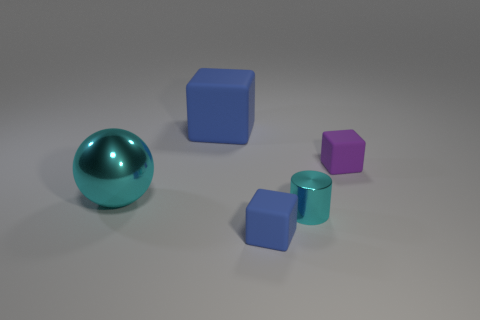Is there anything else that has the same size as the cyan ball?
Your response must be concise. Yes. Does the small blue matte object have the same shape as the large blue object?
Offer a very short reply. Yes. Are there fewer tiny objects that are in front of the cyan cylinder than tiny cyan things that are behind the large blue block?
Your answer should be very brief. No. There is a tiny cyan shiny cylinder; what number of small cyan metal cylinders are to the right of it?
Give a very brief answer. 0. Is the shape of the large thing right of the big metallic object the same as the blue object on the right side of the large blue cube?
Make the answer very short. Yes. What number of other things are there of the same color as the tiny metallic cylinder?
Provide a succinct answer. 1. The blue object in front of the blue matte block to the left of the blue rubber cube that is in front of the big cube is made of what material?
Your answer should be compact. Rubber. What is the material of the cyan object to the right of the blue matte thing that is behind the tiny cyan object?
Provide a short and direct response. Metal. Are there fewer tiny cyan metallic cylinders that are behind the cyan metal cylinder than big blue rubber blocks?
Provide a succinct answer. Yes. What shape is the cyan metallic object in front of the shiny sphere?
Keep it short and to the point. Cylinder. 